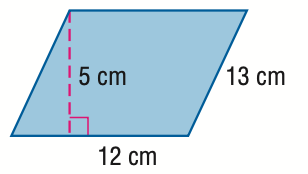Question: Find the area of the parallelogram. Round to the nearest tenth if necessary.
Choices:
A. 30
B. 50
C. 60
D. 156
Answer with the letter. Answer: C 